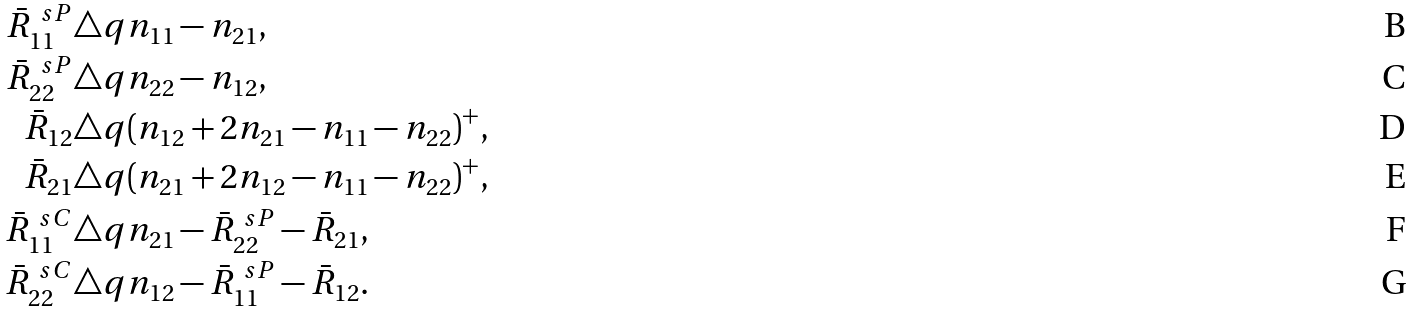<formula> <loc_0><loc_0><loc_500><loc_500>\bar { R } _ { 1 1 } ^ { \ s P } & \triangle q n _ { 1 1 } - n _ { 2 1 } , \\ \bar { R } _ { 2 2 } ^ { \ s P } & \triangle q n _ { 2 2 } - n _ { 1 2 } , \\ \bar { R } _ { 1 2 } & \triangle q ( n _ { 1 2 } + 2 n _ { 2 1 } - n _ { 1 1 } - n _ { 2 2 } ) ^ { + } , \\ \bar { R } _ { 2 1 } & \triangle q ( n _ { 2 1 } + 2 n _ { 1 2 } - n _ { 1 1 } - n _ { 2 2 } ) ^ { + } , \\ \bar { R } _ { 1 1 } ^ { \ s C } & \triangle q n _ { 2 1 } - \bar { R } _ { 2 2 } ^ { \ s P } - \bar { R } _ { 2 1 } , \\ \bar { R } _ { 2 2 } ^ { \ s C } & \triangle q n _ { 1 2 } - \bar { R } _ { 1 1 } ^ { \ s P } - \bar { R } _ { 1 2 } .</formula> 